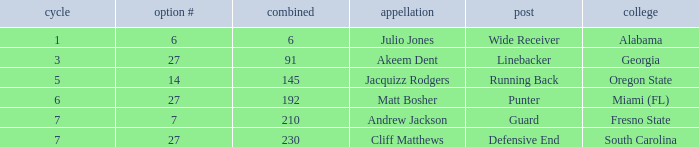Which highest pick number had Akeem Dent as a name and where the overall was less than 91? None. 